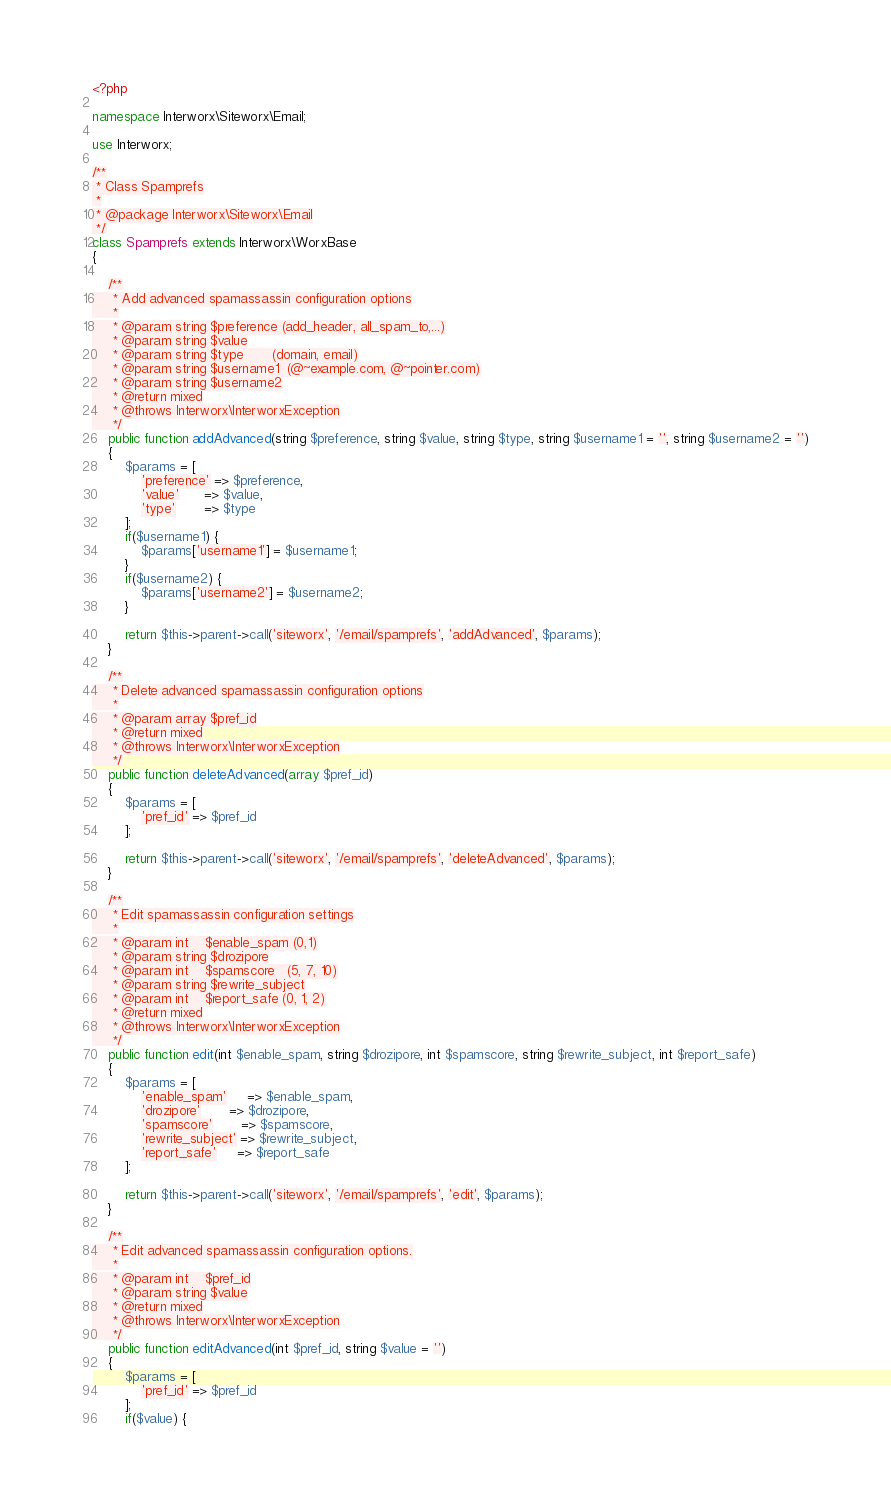Convert code to text. <code><loc_0><loc_0><loc_500><loc_500><_PHP_><?php

namespace Interworx\Siteworx\Email;

use Interworx;

/**
 * Class Spamprefs
 *
 * @package Interworx\Siteworx\Email
 */
class Spamprefs extends Interworx\WorxBase
{

    /**
     * Add advanced spamassassin configuration options
     *
     * @param string $preference (add_header, all_spam_to,...)
     * @param string $value
     * @param string $type       (domain, email)
     * @param string $username1  (@~example.com, @~pointer.com)
     * @param string $username2
     * @return mixed
     * @throws Interworx\InterworxException
     */
    public function addAdvanced(string $preference, string $value, string $type, string $username1 = '', string $username2 = '')
    {
        $params = [
            'preference' => $preference,
            'value'      => $value,
            'type'       => $type
        ];
        if($username1) {
            $params['username1'] = $username1;
        }
        if($username2) {
            $params['username2'] = $username2;
        }

        return $this->parent->call('siteworx', '/email/spamprefs', 'addAdvanced', $params);
    }

    /**
     * Delete advanced spamassassin configuration options
     *
     * @param array $pref_id
     * @return mixed
     * @throws Interworx\InterworxException
     */
    public function deleteAdvanced(array $pref_id)
    {
        $params = [
            'pref_id' => $pref_id
        ];

        return $this->parent->call('siteworx', '/email/spamprefs', 'deleteAdvanced', $params);
    }

    /**
     * Edit spamassassin configuration settings
     *
     * @param int    $enable_spam (0,1)
     * @param string $drozipore
     * @param int    $spamscore   (5, 7, 10)
     * @param string $rewrite_subject
     * @param int    $report_safe (0, 1, 2)
     * @return mixed
     * @throws Interworx\InterworxException
     */
    public function edit(int $enable_spam, string $drozipore, int $spamscore, string $rewrite_subject, int $report_safe)
    {
        $params = [
            'enable_spam'     => $enable_spam,
            'drozipore'       => $drozipore,
            'spamscore'       => $spamscore,
            'rewrite_subject' => $rewrite_subject,
            'report_safe'     => $report_safe
        ];

        return $this->parent->call('siteworx', '/email/spamprefs', 'edit', $params);
    }

    /**
     * Edit advanced spamassassin configuration options.
     *
     * @param int    $pref_id
     * @param string $value
     * @return mixed
     * @throws Interworx\InterworxException
     */
    public function editAdvanced(int $pref_id, string $value = '')
    {
        $params = [
            'pref_id' => $pref_id
        ];
        if($value) {</code> 